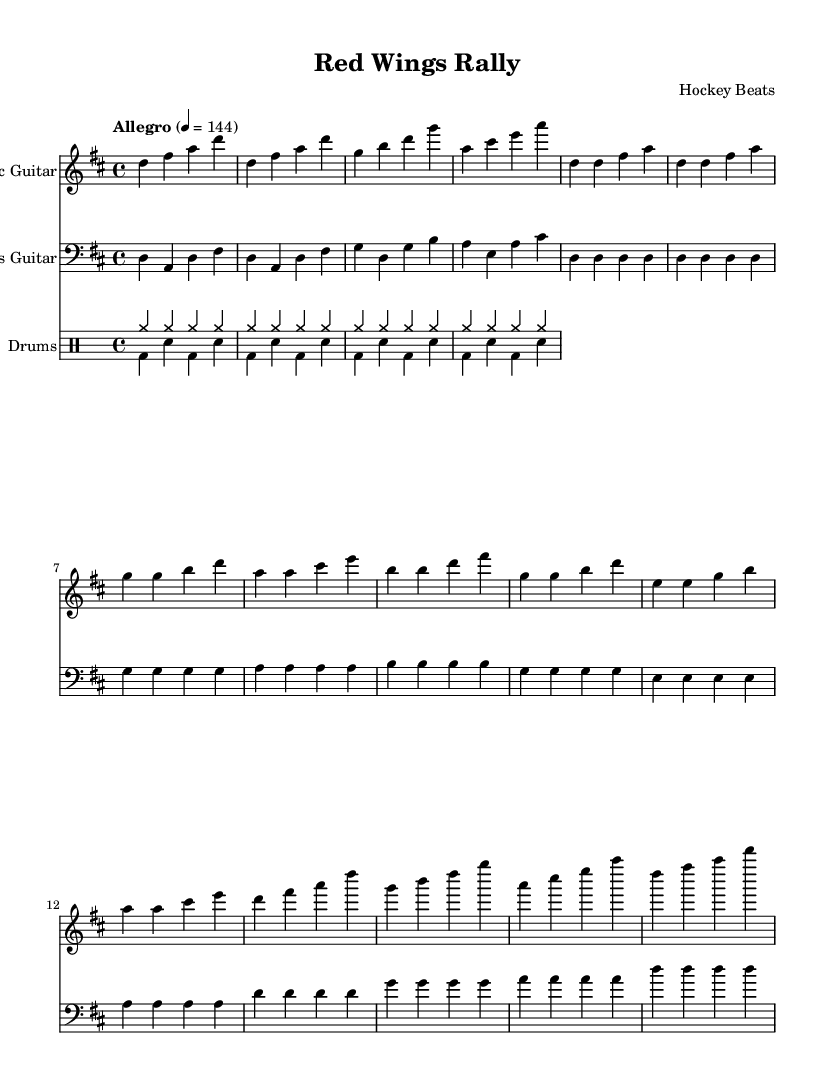What is the key signature of this music? The key signature is D major, which has two sharps: F sharp and C sharp. This is indicated at the beginning of the sheet music.
Answer: D major What is the time signature of the piece? The time signature is 4/4, which means there are four beats per measure and each quarter note receives one beat. This is shown at the beginning of the music.
Answer: 4/4 What is the tempo marking for the music? The tempo marking is "Allegro" indicating a fast tempo, specifically set at 144 beats per minute. This is indicated above the staff in the tempo section.
Answer: Allegro How many instruments are featured in this score? There are three instruments featured: Electric Guitar, Bass Guitar, and Drums. Each is shown in separate staves in the score.
Answer: Three What is the structure of the piece based on the sections indicated? The piece is structured into four main sections: Intro, Verse, Pre-Chorus, and Chorus. Each section has specific measures laid out in the notation.
Answer: Intro, Verse, Pre-Chorus, Chorus What type of song is represented in this sheet music? The song represents a high-energy workout track intended for pre-game motivation, as indicated by the upbeat tempo and rhythmic patterns.
Answer: High-energy workout track 